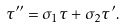Convert formula to latex. <formula><loc_0><loc_0><loc_500><loc_500>\tau ^ { \prime \prime } = \sigma _ { 1 } \tau + \sigma _ { 2 } \tau ^ { \prime } .</formula> 